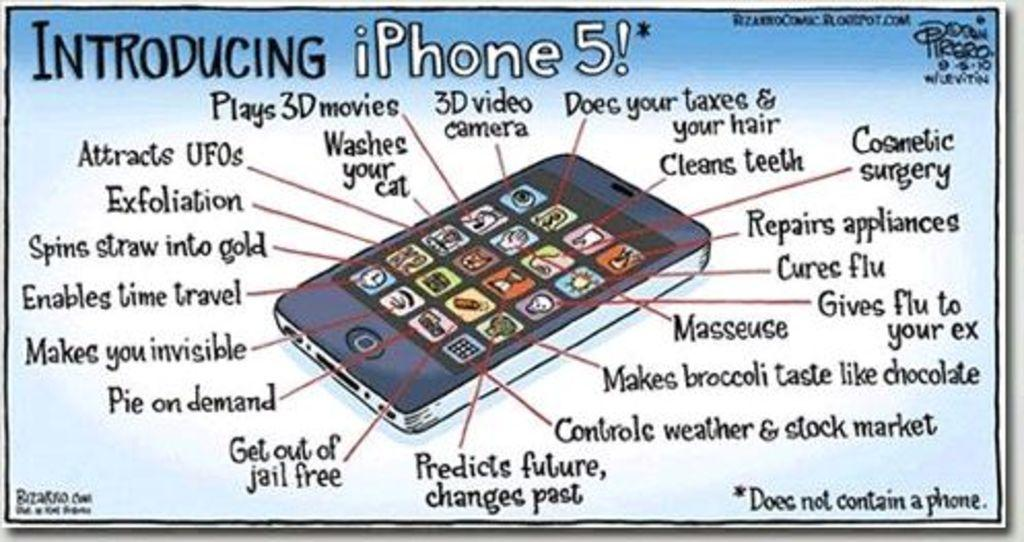What is the main subject of the poster in the image? The poster features a mobile phone. What else can be seen on the poster besides the mobile phone? There is text on the poster. What type of lumber is being used to build the army's coats in the image? There is no lumber, army, or coats present in the image; it only features a poster with a mobile phone and text. 